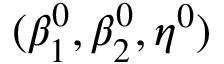<formula> <loc_0><loc_0><loc_500><loc_500>( \beta _ { 1 } ^ { 0 } , \beta _ { 2 } ^ { 0 } , \eta ^ { 0 } )</formula> 